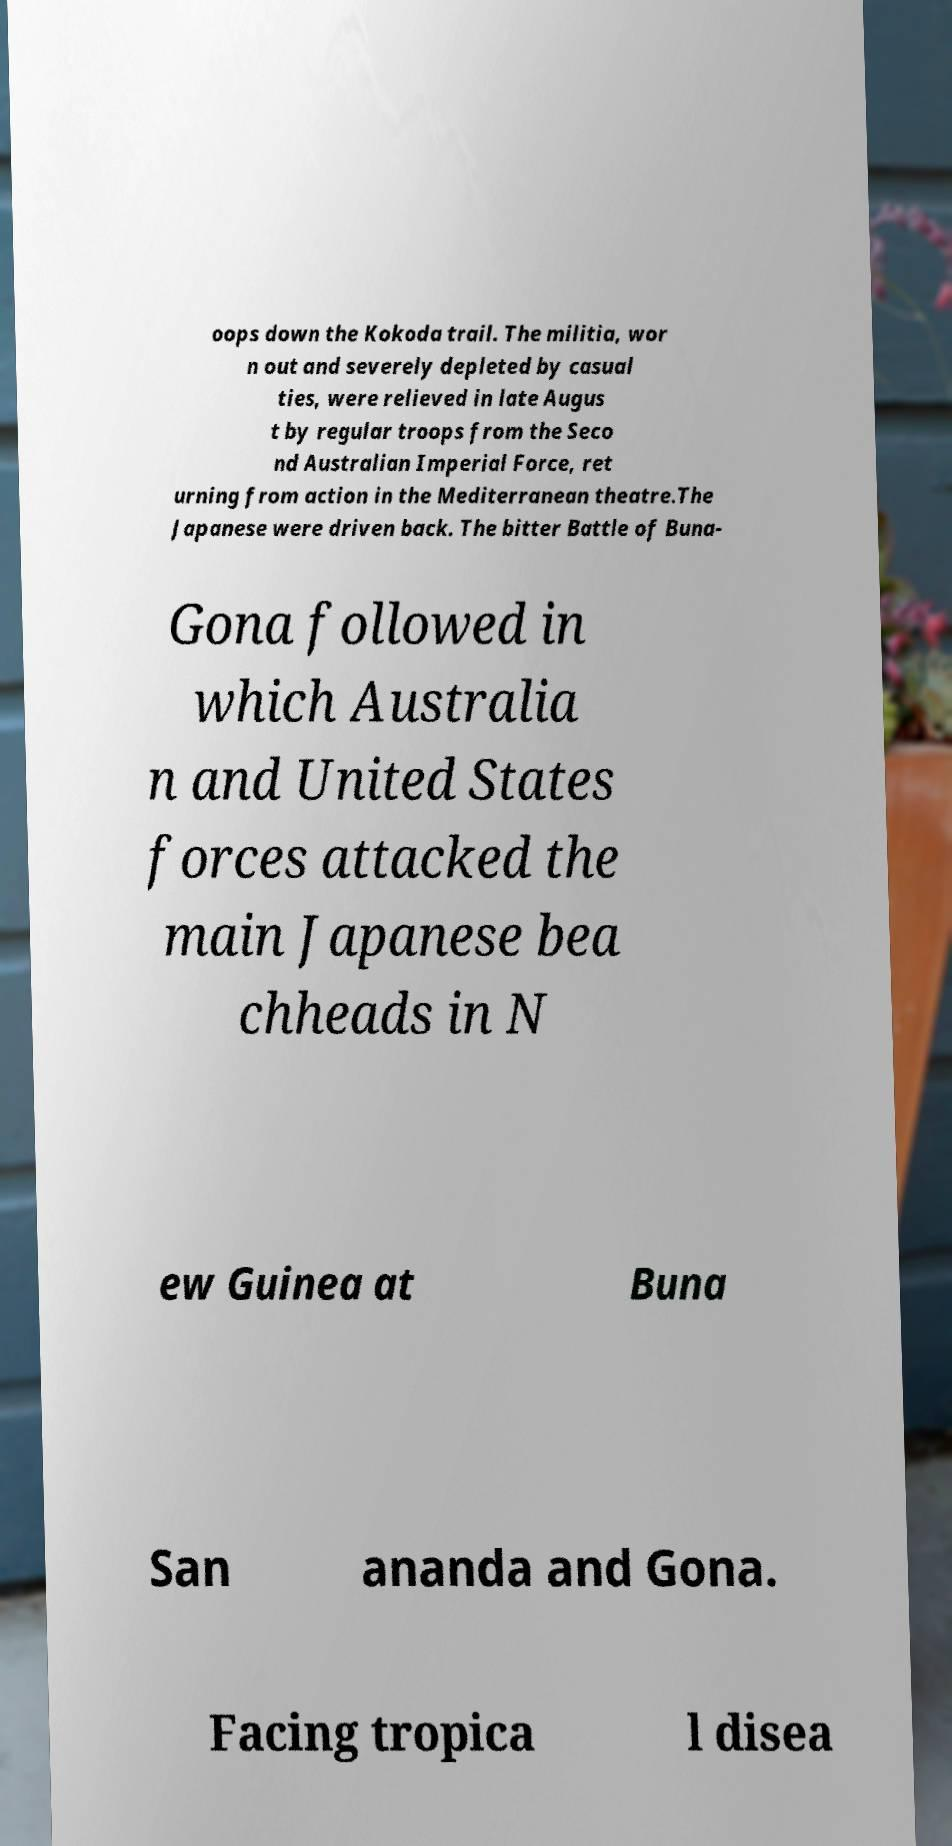Please read and relay the text visible in this image. What does it say? oops down the Kokoda trail. The militia, wor n out and severely depleted by casual ties, were relieved in late Augus t by regular troops from the Seco nd Australian Imperial Force, ret urning from action in the Mediterranean theatre.The Japanese were driven back. The bitter Battle of Buna- Gona followed in which Australia n and United States forces attacked the main Japanese bea chheads in N ew Guinea at Buna San ananda and Gona. Facing tropica l disea 